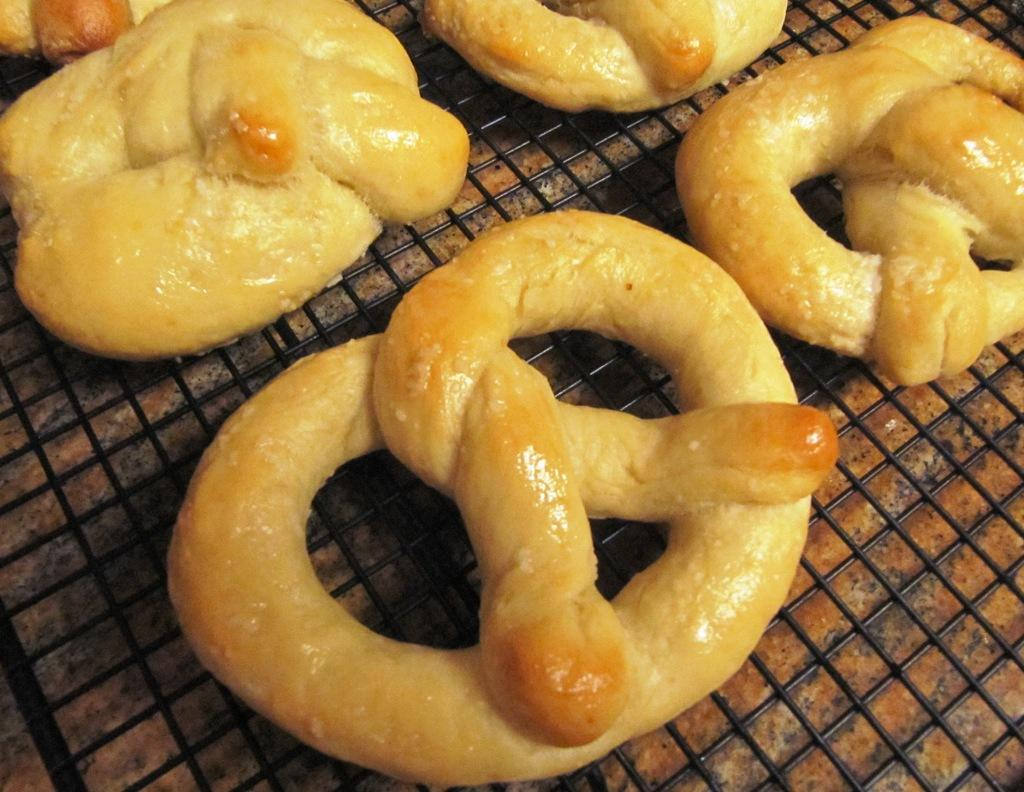What is the main object in the center of the image? There is a table in the center of the image. What is on top of the table? There is a grill on the table. What is being cooked on the grill? There are food items on the grill. What type of bushes can be seen growing near the sea in the image? There is no sea or bushes present in the image; it features a table with a grill and food items. 